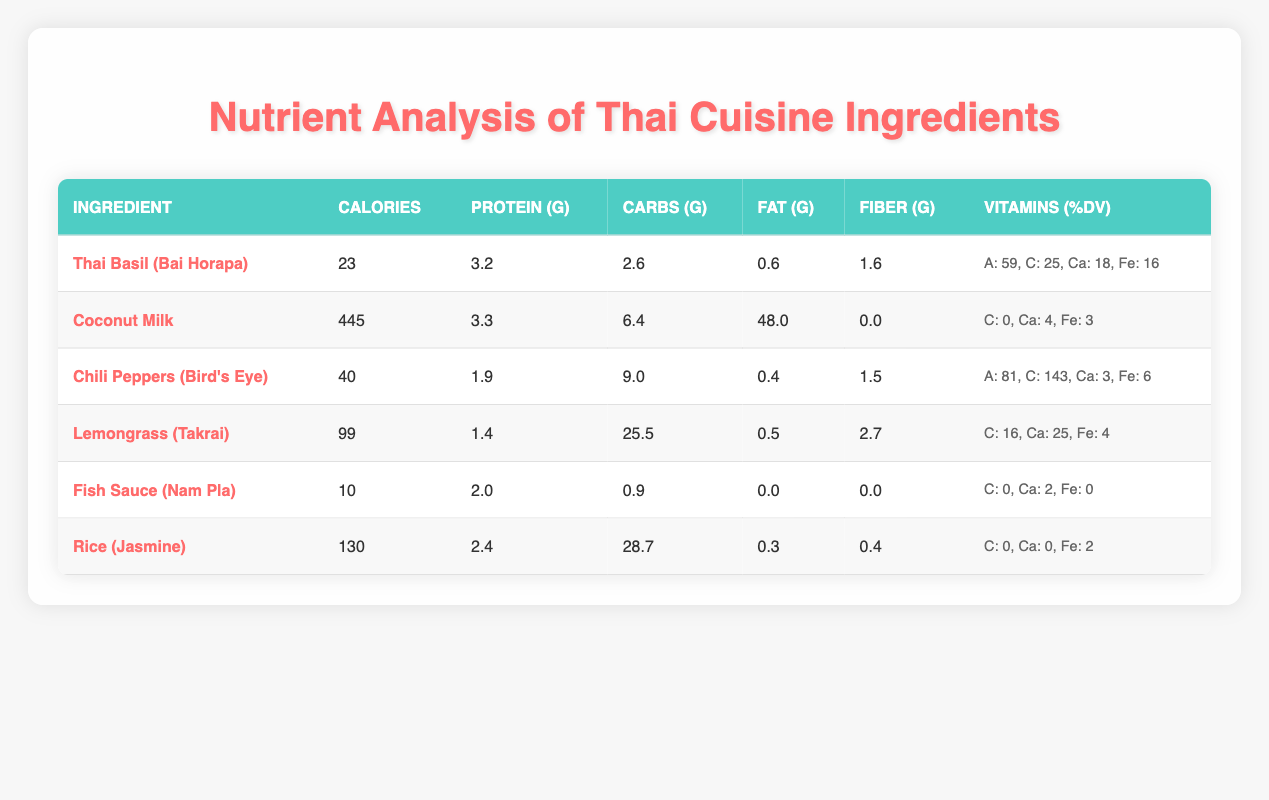What is the calorie content of Coconut Milk? Referring to the table, the row for Coconut Milk indicates that its calorie content is 445.
Answer: 445 Which ingredient has the highest Vitamin C (%DV)? By examining the Vitamin C (%DV) values listed for each ingredient, Chili Peppers (Bird's Eye) has the highest at 143%.
Answer: Chili Peppers (Bird's Eye) What is the total fat content in Thai Basil and Fish Sauce combined? The fat content in Thai Basil is 0.6g and in Fish Sauce is 0.0g. Adding these gives 0.6g + 0.0g = 0.6g.
Answer: 0.6g Does Rice (Jasmine) have any Vitamin C content? Looking at the table, Rice (Jasmine) has a Vitamin C (%DV) value of 0, indicating no Vitamin C content.
Answer: No What is the average protein content of the ingredients listed? The ingredients’ protein content values are 3.2, 3.3, 1.9, 1.4, 2.0, and 2.4 grams. The sum is 14.2 and there are 6 data points; thus, the average is 14.2 / 6 = 2.3667, approximately 2.37 grams.
Answer: 2.37 grams Which ingredient contains the most fiber? By checking the Fiber (g) values in the table, Lemongrass (Takrai) has the highest at 2.7g.
Answer: Lemongrass (Takrai) Is the combined carbohydrate content of Coconut Milk and Jasmine Rice greater than 35g? The carbohydrate content in Coconut Milk is 6.4g and in Jasmine Rice is 28.7g. Adding these gives 6.4g + 28.7g = 35.1g, which is greater than 35g.
Answer: Yes How much Calcium (%DV) is present in Thai Basil? The table indicates that Thai Basil has a Calcium (%DV) value of 18.
Answer: 18 Which ingredient has the least calories? After reviewing the calorie counts for each ingredient, Fish Sauce (Nam Pla) has the least at 10 calories.
Answer: Fish Sauce (Nam Pla) 